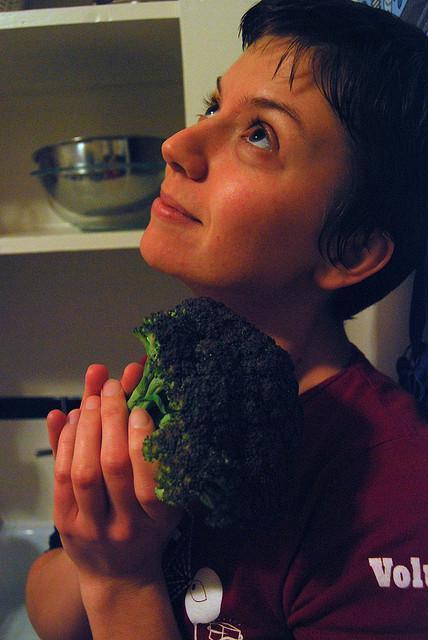Does the image validate the caption "The person is facing away from the broccoli."?
Answer yes or no. Yes. 